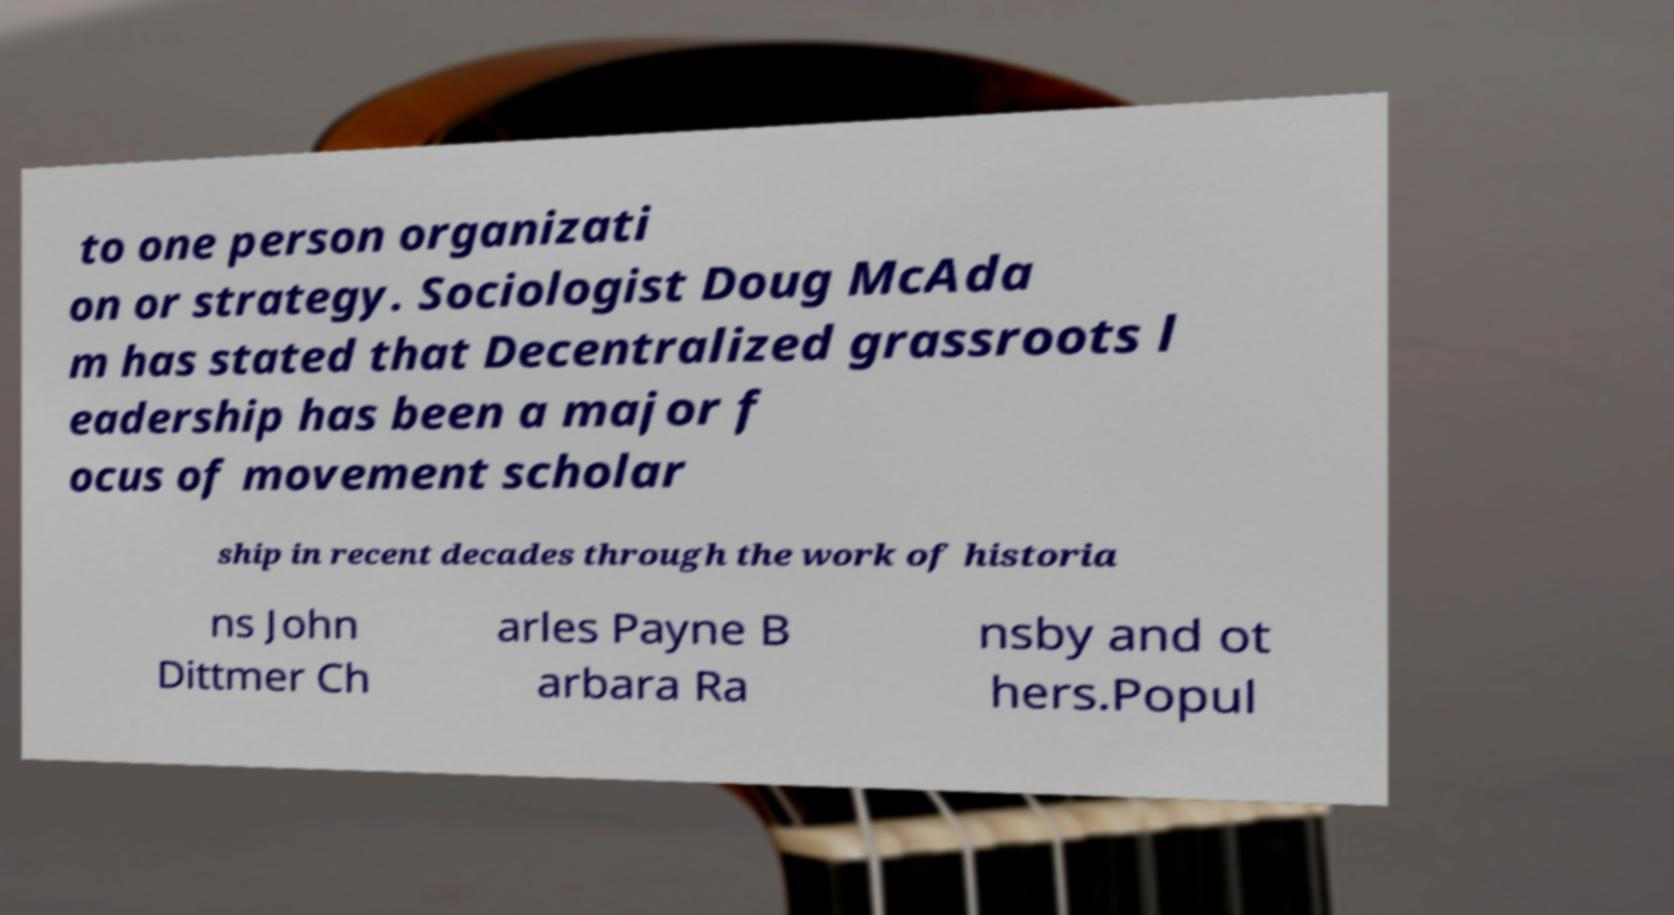I need the written content from this picture converted into text. Can you do that? to one person organizati on or strategy. Sociologist Doug McAda m has stated that Decentralized grassroots l eadership has been a major f ocus of movement scholar ship in recent decades through the work of historia ns John Dittmer Ch arles Payne B arbara Ra nsby and ot hers.Popul 